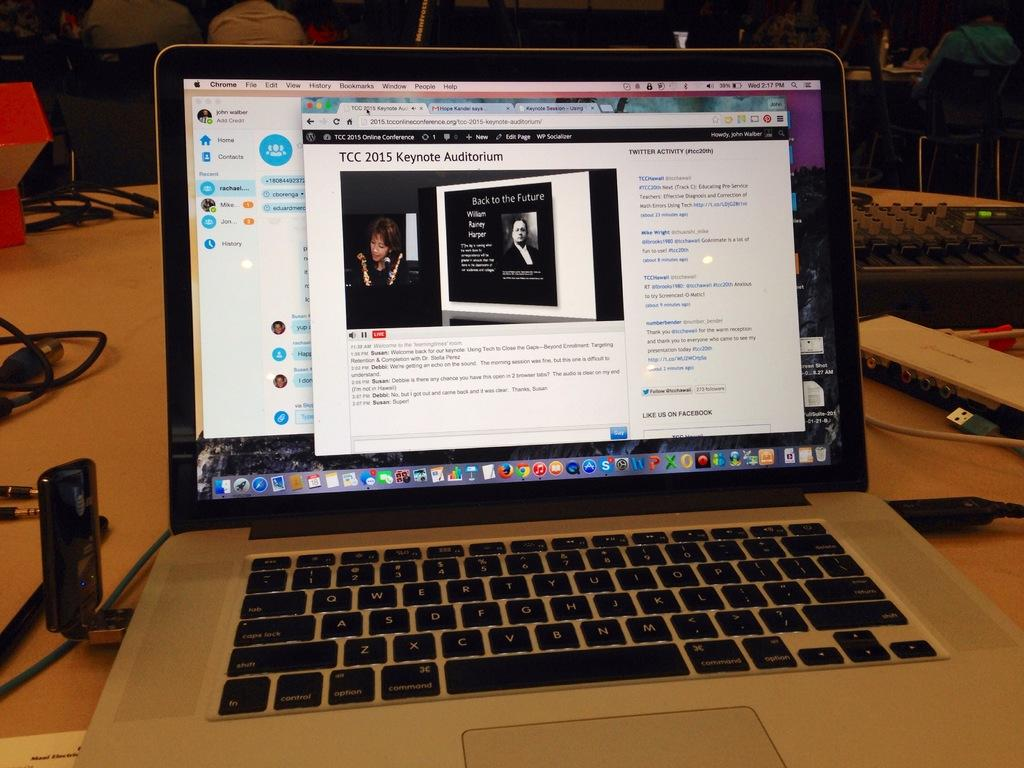Provide a one-sentence caption for the provided image. The laptop on the table is open to a webpage for TCC 2015 Keynote Auditorium. 